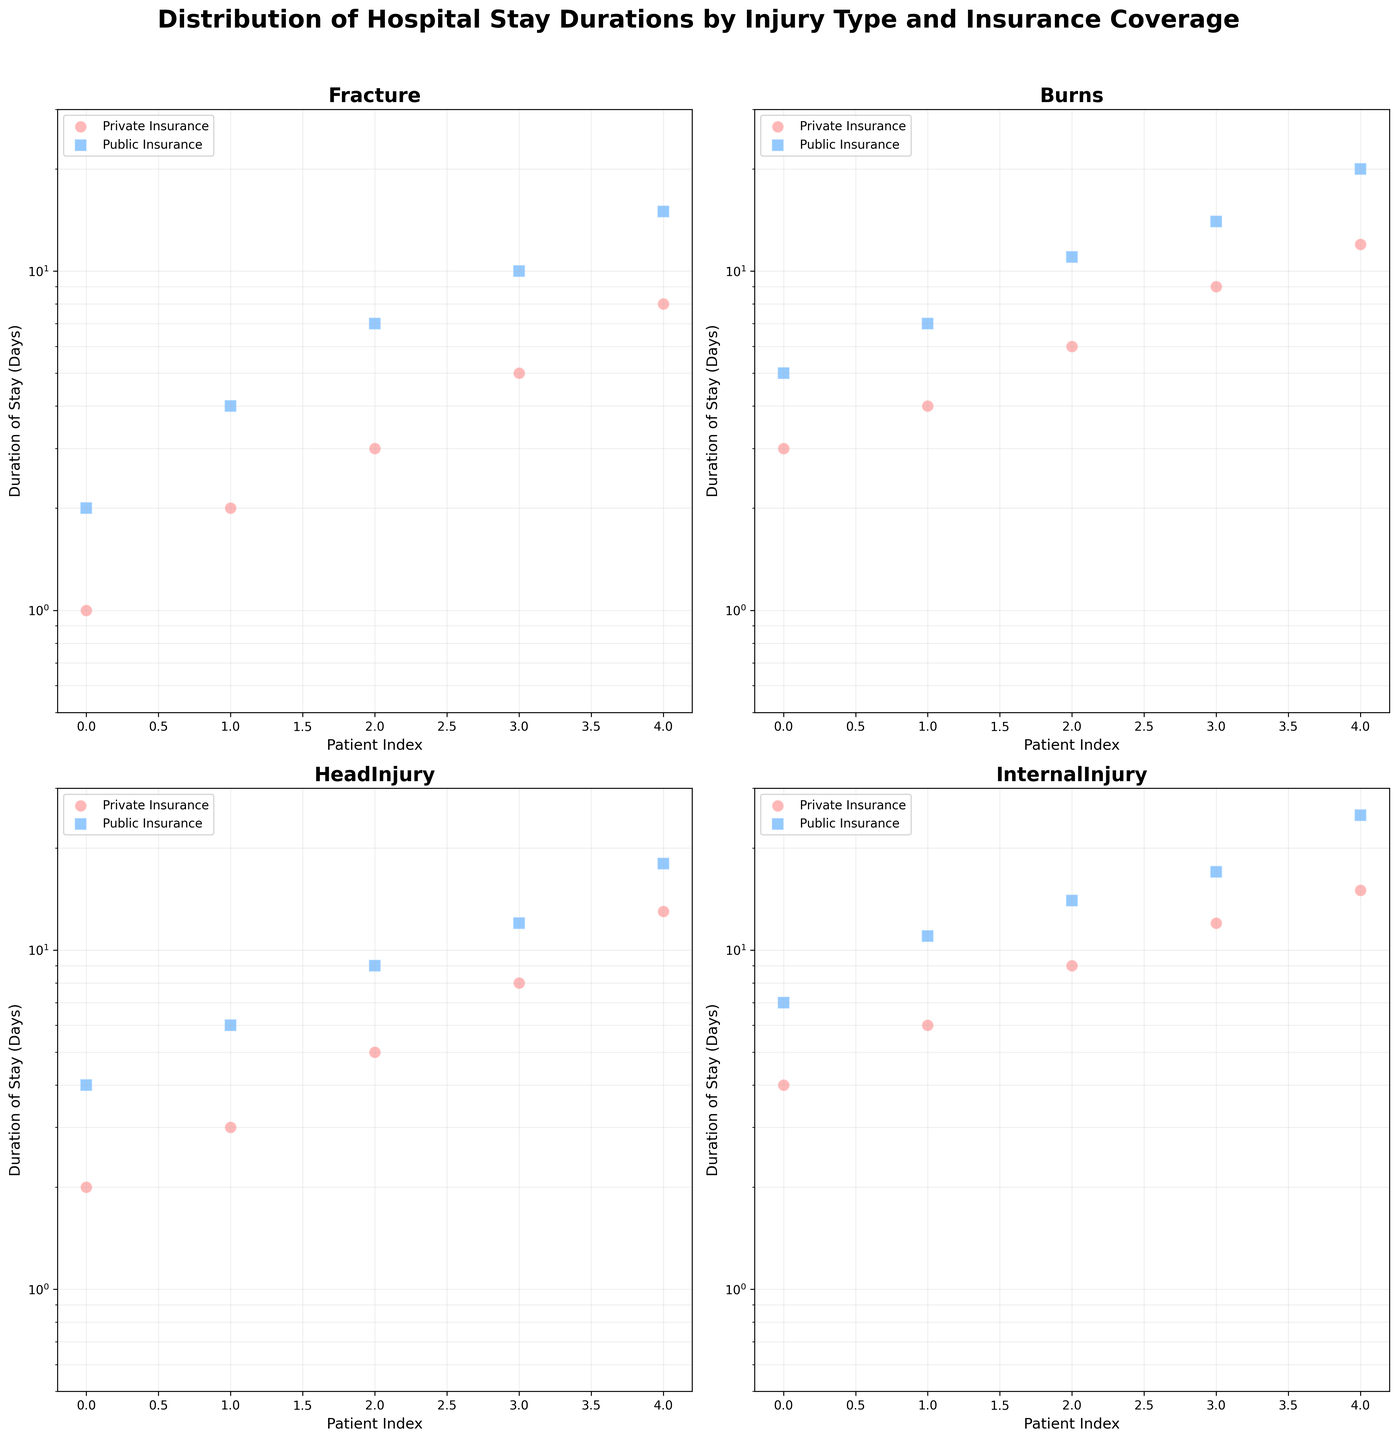How many different injury types are shown in the figure? There are four subplots in the figure, each representing a different injury type.
Answer: Four What is the range of the 'Duration of Stay (Days)' axis in the figure? The y-axis is set to a logarithmic scale with limits from 0.5 to 30 days.
Answer: 0.5 to 30 days Which injury type has the longest hospital stay for a patient with public insurance? From the 'InternalInjury' subplot, we see that the longest hospital stay with public insurance is 25 days.
Answer: InternalInjury Among patients with private insurance, which injury type has a patient with the shortest hospital stay? The 'Fracture' subplot shows the shortest hospital stay for a patient with private insurance, which is 1 day.
Answer: Fracture In which injury type is the difference between the longest stays for private and public insurance maximal? By comparing the longest stays for both insurance types across all injury types, 'InternalInjury' shows the difference is 15 days (public: 25, private: 10).
Answer: InternalInjury For which insurance type are the hospital stays more evenly distributed across 'Burns'? The 'Burns' subplot indicates that patients with public insurance have a wider and more even distribution of stay durations compared to those with private insurance.
Answer: Public Which injury type shows the closest maximum duration of stay between public and private insurance groups? The 'HeadInjury' subplot shows the closest maximum stay durations, with private at 13 days and public at 18 days.
Answer: HeadInjury Is the average duration of stay higher for patients with burns or internal injuries among those with public insurance? Internally injured patients with public insurance have longer durations on average, mostly exceeding 11 days, while burns peak closer to 11.
Answer: InternalInjury How does the duration of stay for head injuries compare for the first three patients with private insurance vis-à-vis public insurance? For the first three patients in the 'HeadInjury' subplot: Private Insurance stays are 2, 3, and 5 days; Public Insurance stays are 4, 6, and 9 days. The public stays are noticeably longer.
Answer: Public (longer) Are there any injury types where the duration of stay for public insurance is uniformly longer than that for private insurance? In the 'InternalInjury' subplot, every data point for public insurance is greater than the corresponding data points for private insurance.
Answer: InternalInjury 